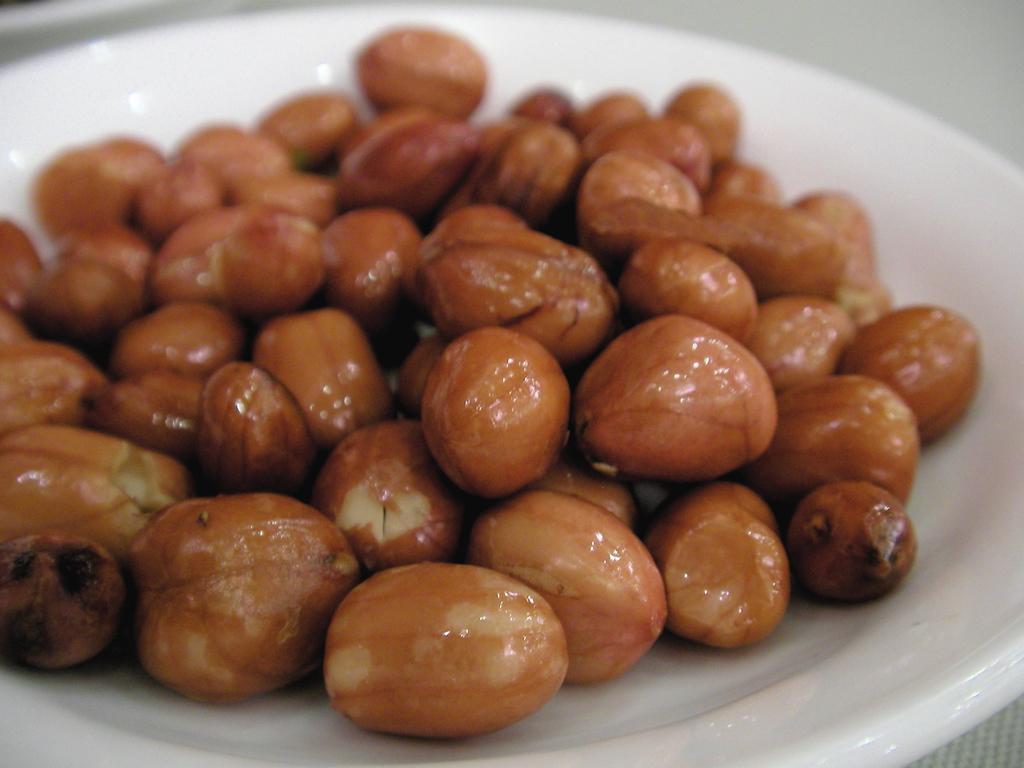In one or two sentences, can you explain what this image depicts? In this image we can see some food items on the plate, and the background is blurred. 